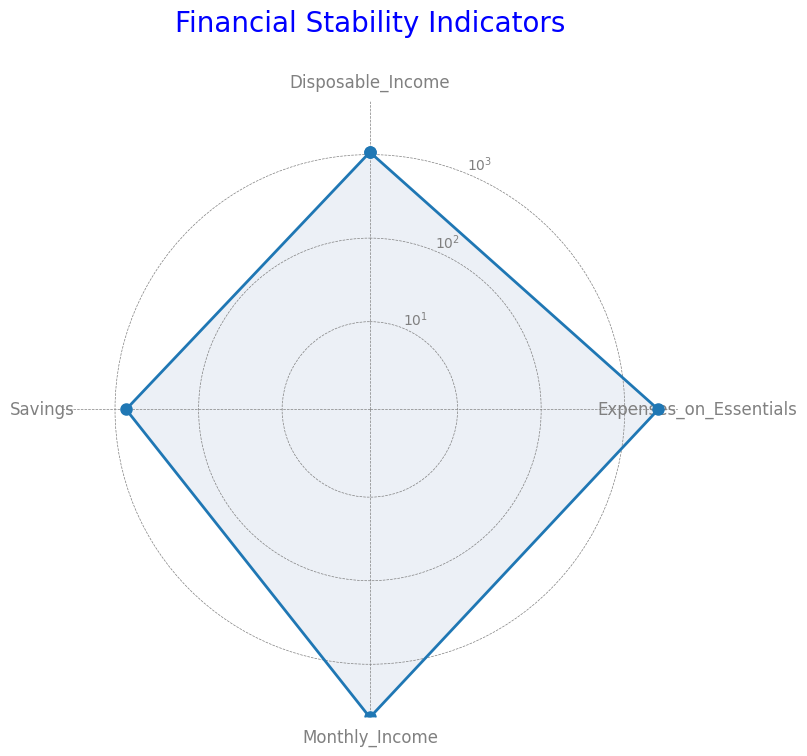What is the average monthly income? To find the average monthly income, sum all the values for Monthly_Income (4000 + 4500 + 3800 + 5000 + 4200 + 4600 + 4100 + 4400) and divide by the number of data points (8)
Answer: 4325 How much more is the highest disposable income compared to the lowest disposable income? Identify the highest and lowest values for Disposable_Income. The highest is 1300, and the lowest is 850. Subtract the lowest from the highest (1300 - 850)
Answer: 450 Are savings generally higher or lower than disposable income? Compare the average values for Savings and Disposable_Income. Savings average to 738, and Disposable_Income averages to 1069.
Answer: Lower What is the difference in average values between monthly income and expenses on essentials? Calculate the average for Monthly_Income (4325) and Expenses_on_Essentials (2512.5) and find the difference (4325 - 2512.5)
Answer: 1812.5 Which category has the smallest average value? Compare the average values for all categories: Monthly_Income (4325), Savings (738), Expenses_on_Essentials (2512.5), and Disposable_Income (1069) to find the smallest
Answer: Savings Which category shows the most consistency in values throughout the dataset? Evaluate the variance in values for each category: Monthly_Income, Savings, Expenses_on_Essentials, Disposable_Income. The category with the smallest variance is most consistent.
Answer: Expenses_on_Essentials How does the visual representation highlight the difference between savings and disposable income? Observe the lengths of the lines in the radar chart representing Savings and Disposable_Income. Disposable_Income's line will be further from the center compared to Savings.
Answer: Disposable income is significantly higher visually 